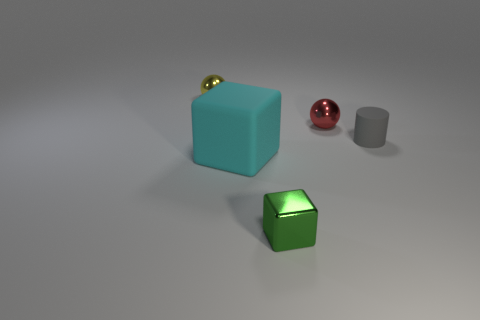There is another rubber object that is the same size as the red thing; what is its shape?
Your answer should be very brief. Cylinder. The cyan cube is what size?
Make the answer very short. Large. Does the cyan block have the same material as the small yellow sphere?
Offer a terse response. No. What number of yellow metallic things are in front of the shiny object behind the shiny sphere to the right of the cyan thing?
Your answer should be very brief. 0. What shape is the metallic object that is in front of the big cyan cube?
Your response must be concise. Cube. How many other objects are the same material as the tiny yellow thing?
Offer a very short reply. 2. Is the number of green shiny blocks behind the yellow metal ball less than the number of yellow metallic things that are on the left side of the small red sphere?
Make the answer very short. Yes. What color is the other big thing that is the same shape as the green shiny thing?
Offer a terse response. Cyan. Is the size of the red metallic sphere in front of the yellow metallic object the same as the tiny yellow metal sphere?
Provide a short and direct response. Yes. Is the number of small green blocks that are behind the small green metal cube less than the number of small green metal blocks?
Ensure brevity in your answer.  Yes. 